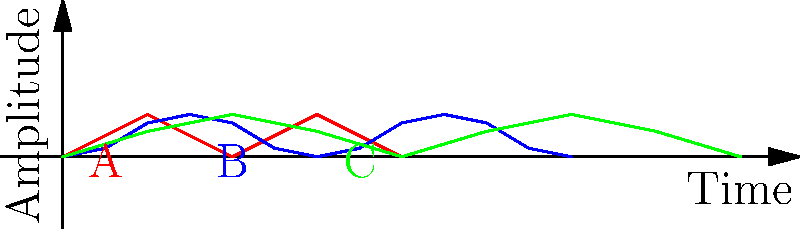As a spiritual guide teaching mindfulness techniques, you often emphasize the importance of breath awareness. The diagram shows three different breathing patterns (A, B, and C) represented as waveforms. Which pattern most likely represents the calm, balanced breathing often achieved during deep meditation? To answer this question, let's analyze each breathing pattern:

1. Pattern A (Red):
   - Shows a regular, symmetrical pattern
   - Equal time for inhalation and exhalation
   - Moderate amplitude, indicating balanced depth of breath

2. Pattern B (Blue):
   - Irregular pattern with sharp peaks
   - Quick inhalations followed by longer exhalations
   - Variable amplitude, suggesting uneven breath depth

3. Pattern C (Green):
   - Smooth, wavelike pattern
   - Gradual rise and fall in amplitude
   - Longer cycles, indicating slower breathing

In deep meditation, practitioners typically achieve a state of calm, rhythmic breathing characterized by:
- Regularity and consistency
- Balance between inhalation and exhalation
- Moderate depth, neither too shallow nor too deep
- Slower pace compared to normal breathing

Comparing these characteristics to the given patterns:
- Pattern A shows regularity and balance, but may be slightly faster than ideal for deep meditation.
- Pattern B is irregular and unbalanced, unlikely in a meditative state.
- Pattern C demonstrates smoothness, regularity, and a slower pace, most closely aligning with the breathing pattern typically observed in deep meditation.

Therefore, Pattern C (Green) most likely represents the calm, balanced breathing often achieved during deep meditation.
Answer: Pattern C (Green) 